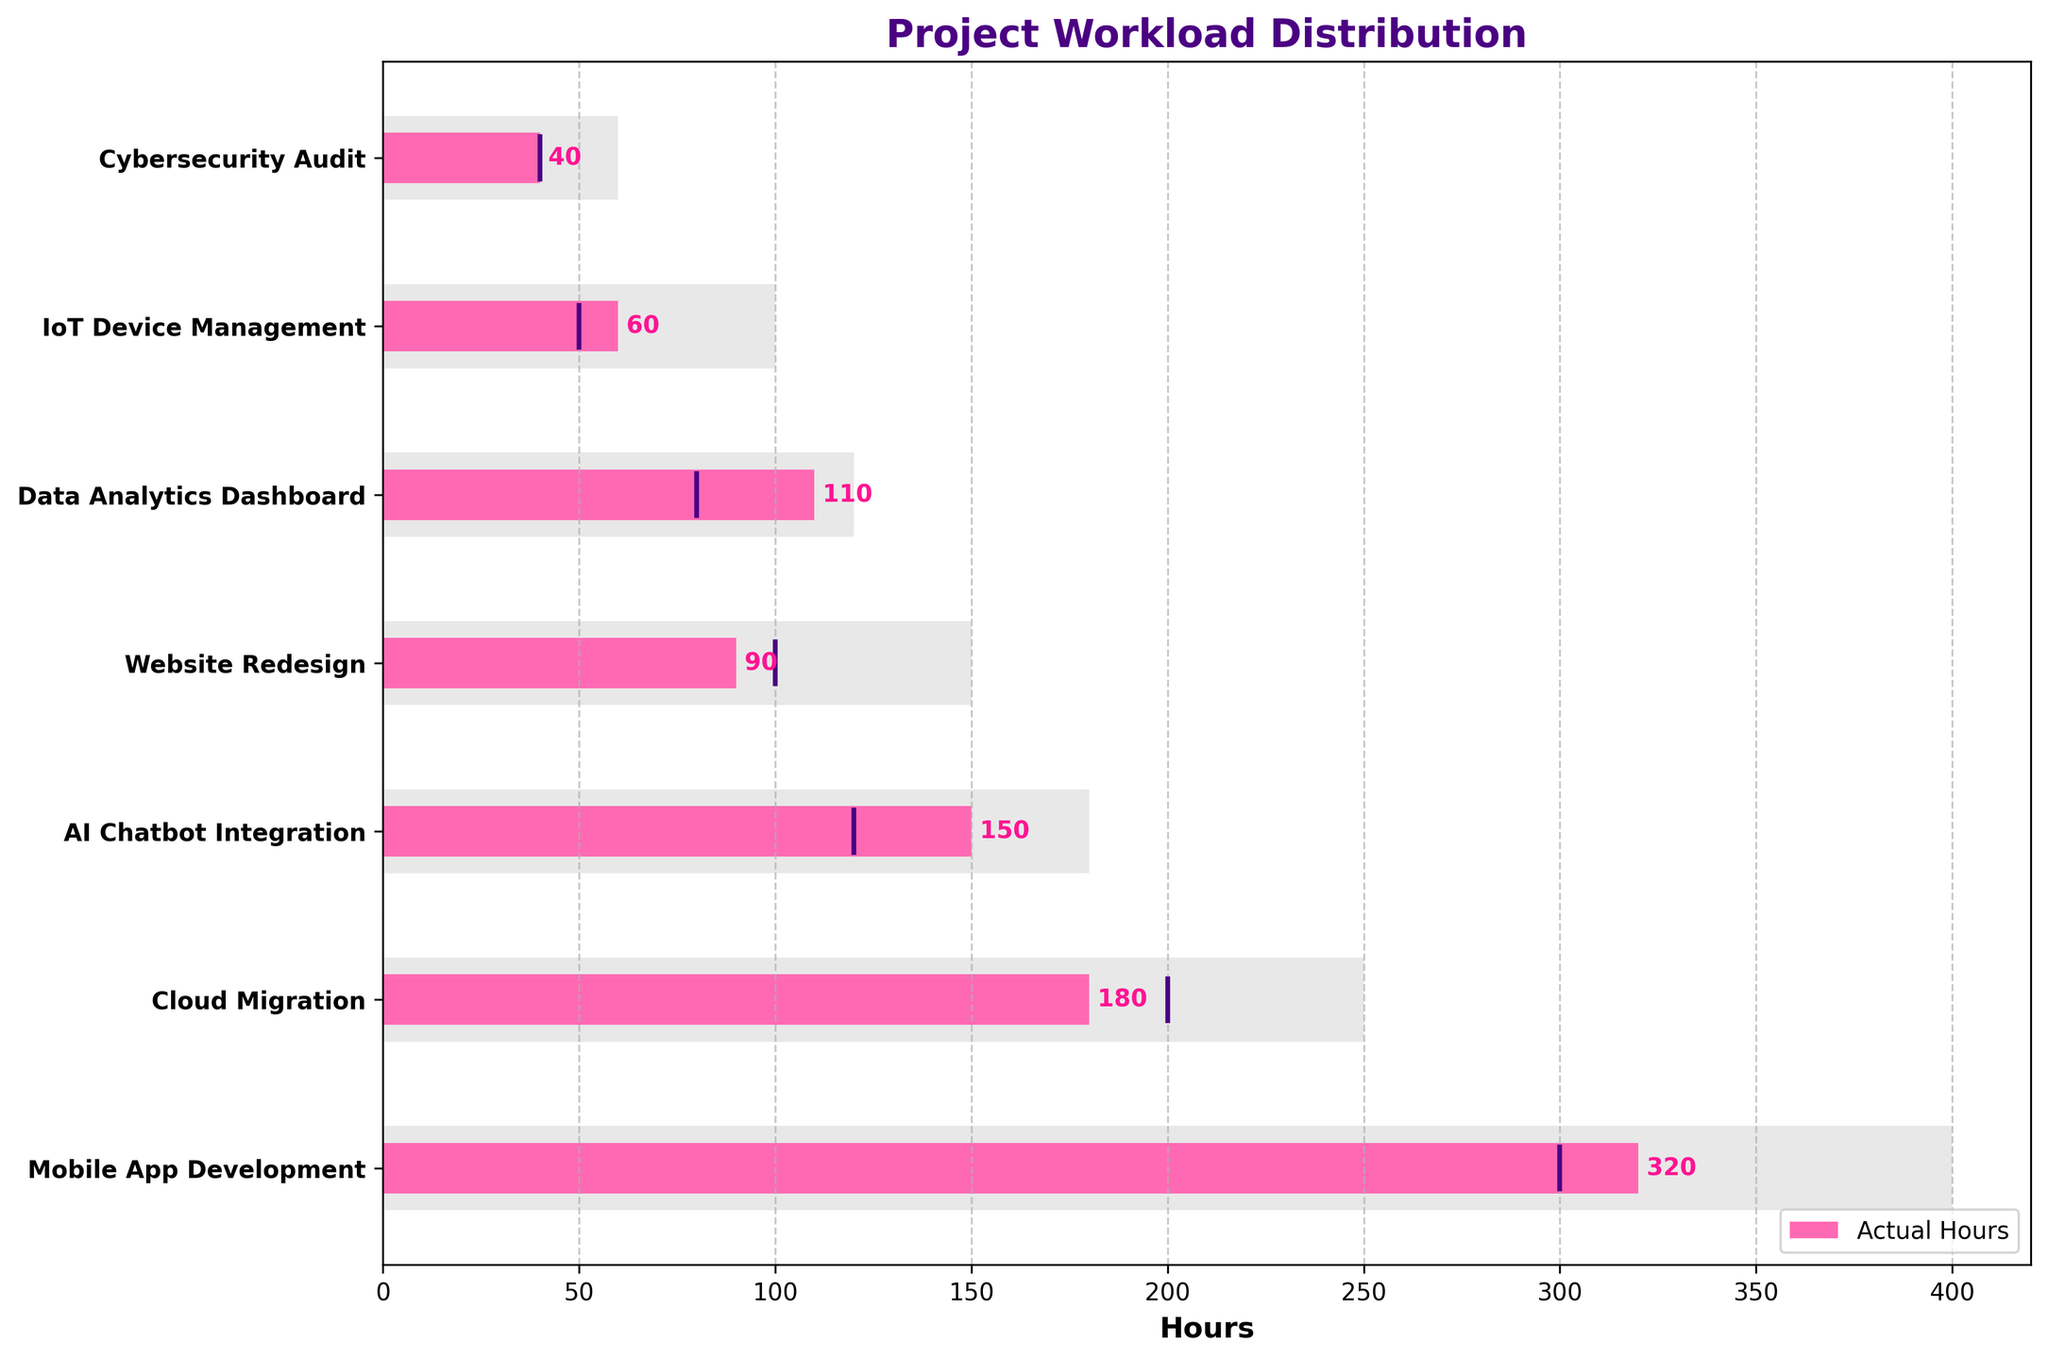What's the title of the plot? The title of the plot is shown at the very top of the figure.
Answer: Project Workload Distribution What do the pink bars represent? The pink bars represent the actual hours spent on each project. This is indicated by the legend in the lower right corner.
Answer: Actual Hours Which project has the highest actual hours worked? By comparing the lengths of the pink bars, the Mobile App Development project clearly has the longest bar, indicating the highest actual hours worked.
Answer: Mobile App Development Are there any projects where the actual hours are equal to the target hours? We need to look at the vertical lines (target hours) and see where they intersect with the ends of the pink bars (actual hours). In the Cybersecurity Audit project, the vertical line and the pink bar end at the same length, suggesting they are equal.
Answer: Cybersecurity Audit What is the difference between the actual and target hours for the AI Chatbot Integration project? The actual hours for the AI Chatbot Integration project are 150 and the target hours are 120. The difference is calculated by subtracting the target hours from the actual hours: 150 - 120.
Answer: 30 Which project has the smallest maximum hours? By comparing all the light grey bars, the shortest one corresponds to the Cybersecurity Audit project, indicating the smallest maximum hours.
Answer: Cybersecurity Audit How many projects have actual hours greater than the target hours? We need to compare each project's actual hours (pink bars) to its target hours (vertical lines). The projects where the pink bar extends beyond the vertical line include Mobile App Development, AI Chatbot Integration, Data Analytics Dashboard, and IoT Device Management. There are four such projects.
Answer: 4 Which project has the largest discrepancy between actual and maximum hours? To find the largest discrepancy, we need to subtract the actual hours from the maximum hours for each project and compare. Mobile App Development has the largest gap (400 - 320 = 80 hours).
Answer: Mobile App Development How many projects have actual hours below the target hours? We need to count the projects where the pink bars are shorter than the vertical lines. The projects in this category include Cloud Migration and Website Redesign. There are two such projects.
Answer: 2 Is the actual hours value higher than the target hours in the IoT Device Management project? Yes, in the IoT Device Management project, the pink bar indicating actual hours extends farther than the vertical line indicating the target hours, which means the actual hours are higher.
Answer: Yes 